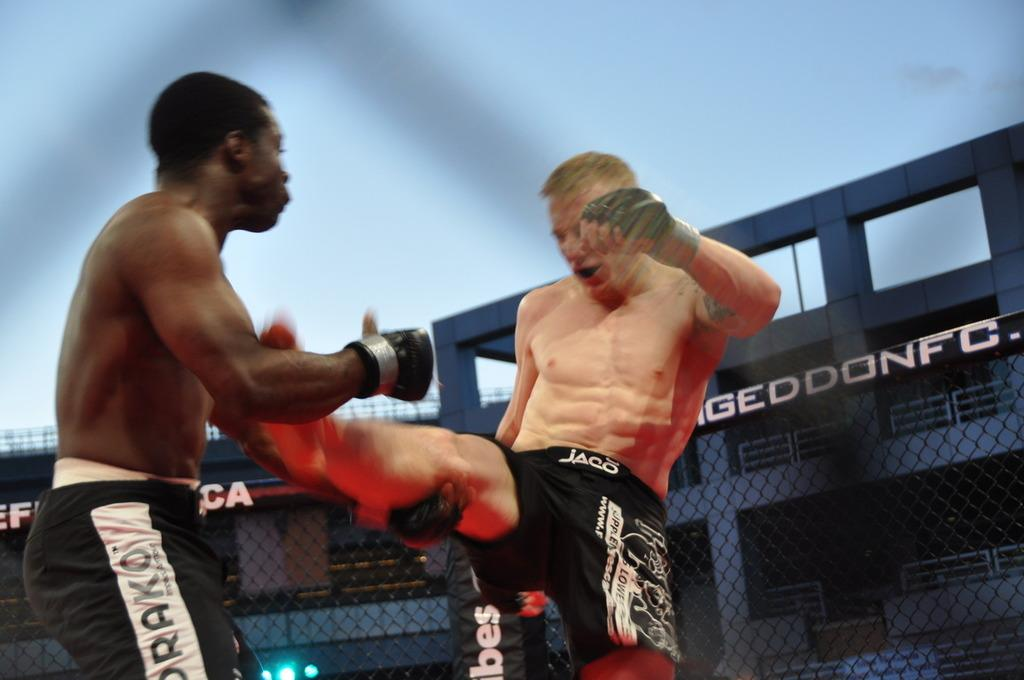Provide a one-sentence caption for the provided image. An ongoing fight during a match sponsored by the Armageddon Fighting Championship. 